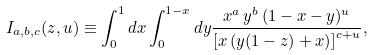Convert formula to latex. <formula><loc_0><loc_0><loc_500><loc_500>I _ { a , b , c } ( z , u ) \equiv \int _ { 0 } ^ { 1 } d x \int _ { 0 } ^ { 1 - x } d y \frac { x ^ { a } \, y ^ { b } \, ( 1 - x - y ) ^ { u } } { \left [ x \left ( y ( 1 - z ) + x \right ) \right ] ^ { c + u } } ,</formula> 